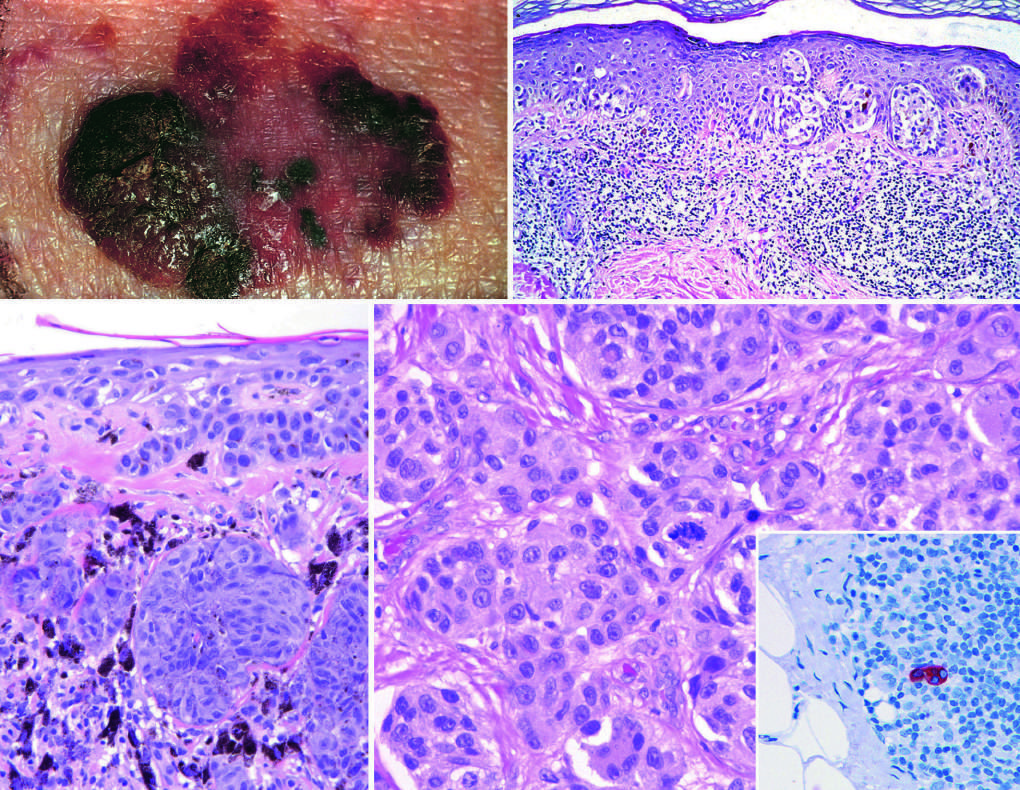do proliferating stromal cells indicate superficial growth, while elevated areas indicate dermal invasion vertical growth?
Answer the question using a single word or phrase. No 